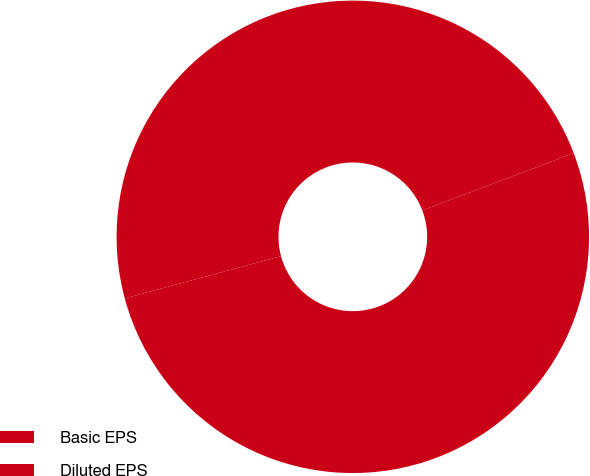Convert chart to OTSL. <chart><loc_0><loc_0><loc_500><loc_500><pie_chart><fcel>Basic EPS<fcel>Diluted EPS<nl><fcel>51.57%<fcel>48.43%<nl></chart> 